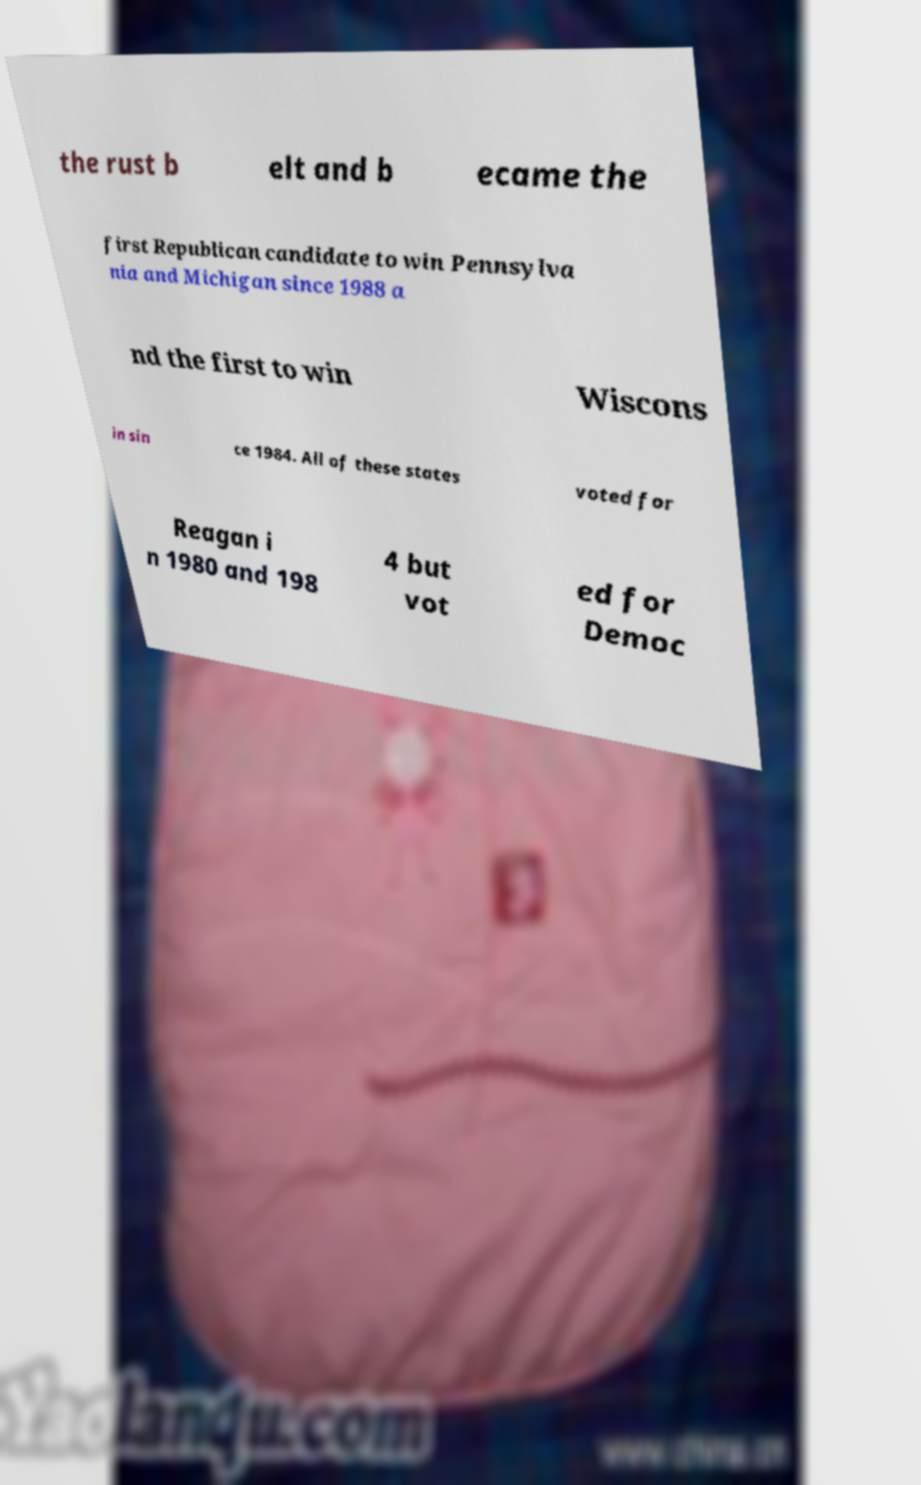Can you accurately transcribe the text from the provided image for me? the rust b elt and b ecame the first Republican candidate to win Pennsylva nia and Michigan since 1988 a nd the first to win Wiscons in sin ce 1984. All of these states voted for Reagan i n 1980 and 198 4 but vot ed for Democ 